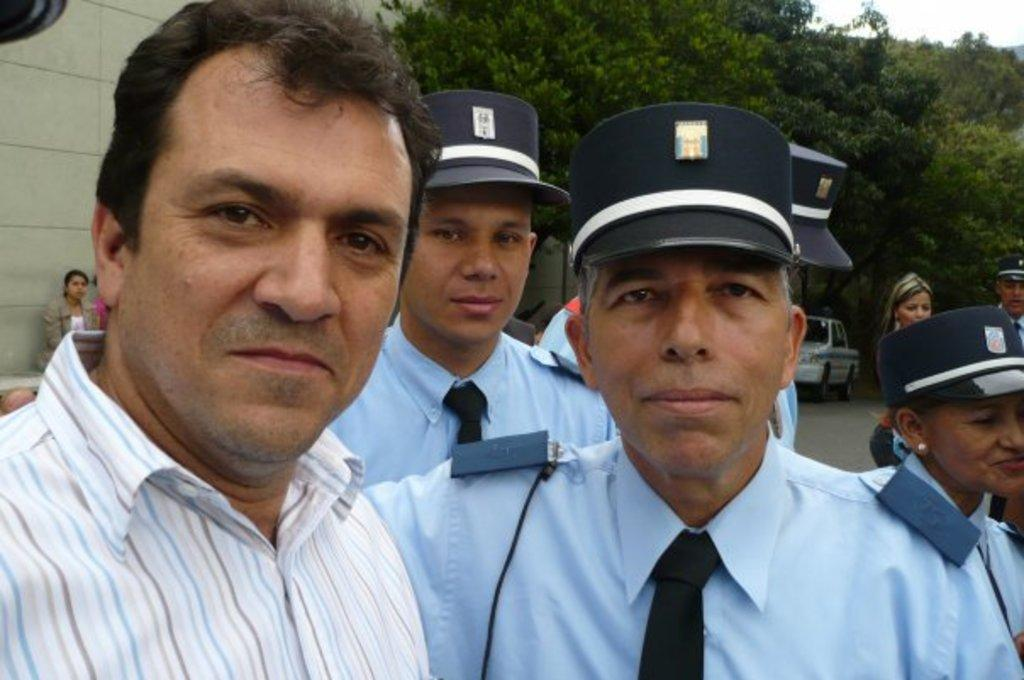How many people are present in the image? There are many people in the image. What are some people wearing in the image? Some people are wearing caps in the image. What can be seen in the background of the image? There is a vehicle in the background of the image. What type of vegetation is present in the image? There are trees in the image. What is on the left side of the image? There is a wall on the left side of the image. What is visible at the top of the image? The sky is visible at the top of the image. What type of appliance can be seen in the image? There is no appliance present in the image. What type of waves can be seen in the image? There are no waves present in the image. 